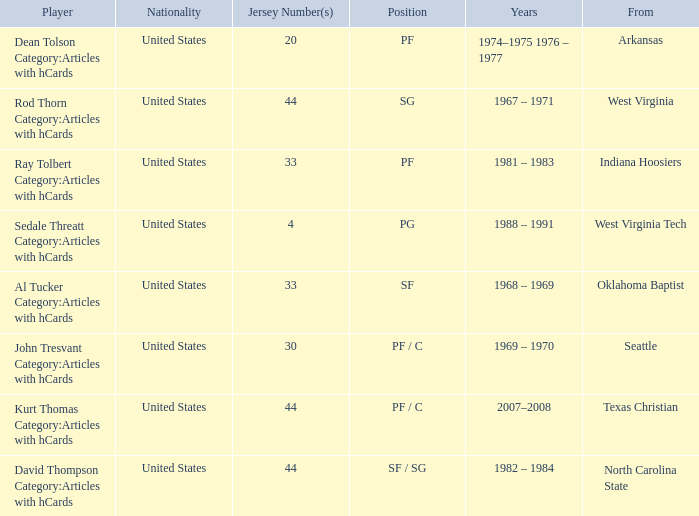What was the highest jersey number for the player from oklahoma baptist? 33.0. 